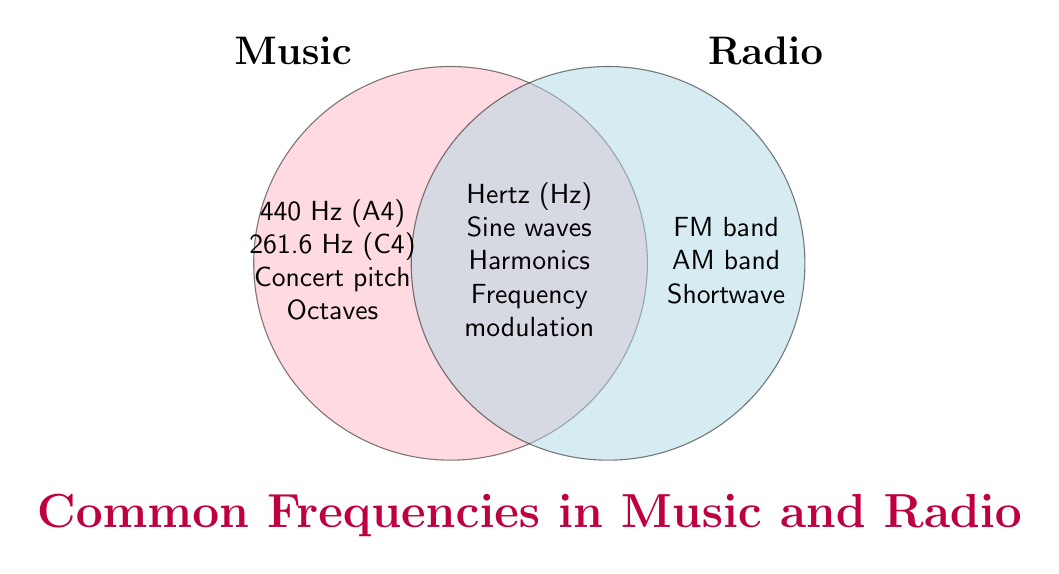Which item is represented both in music and radio? The overlapping area between the two circles represents items common to both sets. These are Hertz (Hz), Sine waves, Harmonics, and Frequency modulation.
Answer: Hertz (Hz), Sine waves, Harmonics, Frequency modulation What items are exclusive to music? The left circle contains items exclusive to music, including 440 Hz (A4), 261.6 Hz (C4), Concert pitch, and Octaves.
Answer: 440 Hz (A4), 261.6 Hz (C4), Concert pitch, Octaves Which items are found only in the radio category? The right circle contains items exclusive to radio, including FM band, AM band, and Shortwave.
Answer: FM band, AM band, Shortwave How many items are common to both music and radio? Count the items in the overlapping section of both circles. There are four items.
Answer: 4 Between music and radio, which has more unique items and by how many? Count the unique items in both circles. Music has four unique items, and radio has three. The difference is one item.
Answer: Music, by one item Which category includes 'Octaves'? 'Octaves' is listed within the left circle representing music.
Answer: Music Is 'Frequency modulation' common to both categories or specific to one? 'Frequency modulation' is situated in the overlapping section, indicating it is common to both music and radio.
Answer: Both Do '440 Hz (A4)' and 'Harmonics' belong to the same category? '440 Hz (A4)' is in music, while 'Harmonics' is in the overlapping section, indicating it belongs to both. So, they share a common link but are not in the same exclusive category.
Answer: No Which category includes the 'FM band'? 'FM band' is in the right circle, which represents radio.
Answer: Radio Can 'Concert pitch' be found in both music and radio? 'Concert pitch' is found exclusively in the left circle labeled music, not in the overlapping section.
Answer: No 